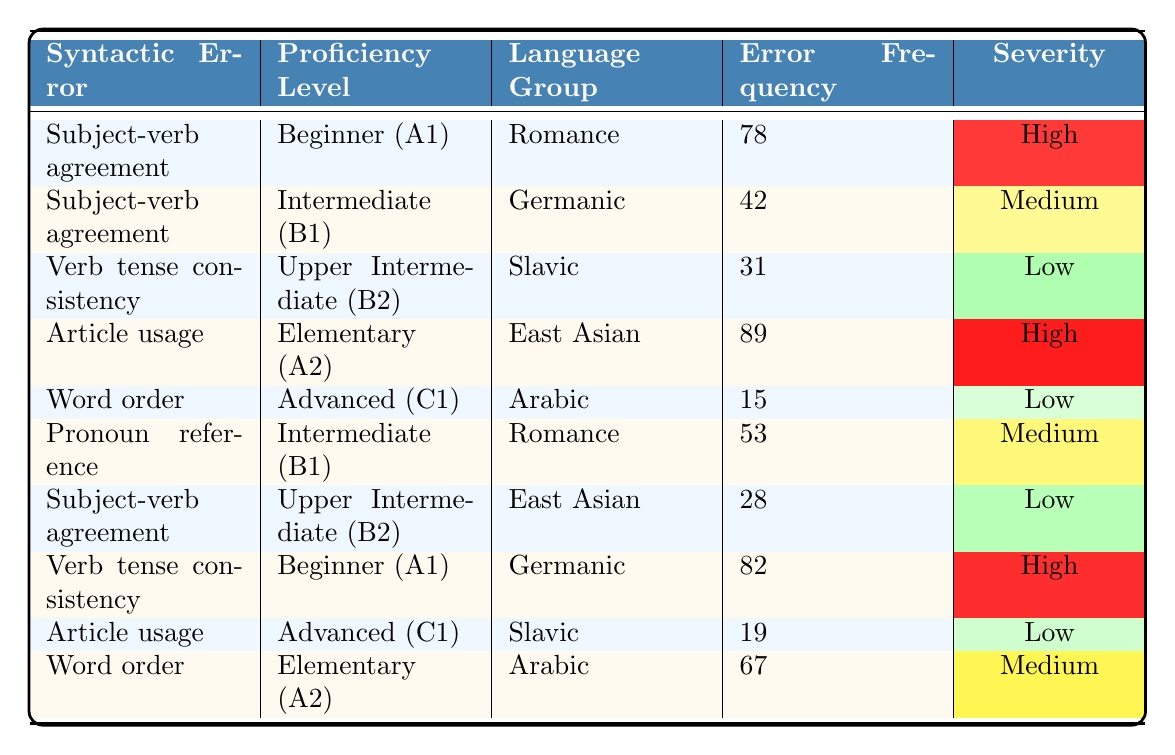What is the highest frequency of syntactic errors in the table? The highest error frequency in the table is found in the "Article usage" error type for the "Elementary (A2)" proficiency level with a frequency of 89.
Answer: 89 In which proficiency level does "Verb tense consistency" have the highest error frequency? "Verb tense consistency" appears twice in the table: once for the "Upper Intermediate (B2)" level with a frequency of 31, and once for "Beginner (A1)" with a frequency of 82. Therefore, "Beginner (A1)" has the higher frequency.
Answer: Beginner (A1) What is the total number of syntactic errors recorded for the "Advanced (C1)" proficiency level? The "Advanced (C1)" level has two entries in the table: "Word order" with a frequency of 15 and "Article usage" with a frequency of 19. Summing these gives 15 + 19 = 34.
Answer: 34 Is there any language group that has a high severity for "Subject-verb agreement"? Yes, the "Romance" language group has a "Subject-verb agreement" frequency of 78 categorized as high severity.
Answer: Yes How many different types of syntactic errors are associated with the "Elementary (A2)" proficiency level? The "Elementary (A2)" level lists two types of errors: "Article usage" with a frequency of 89 and "Verb tense consistency" with a frequency of 71. Thus, there are 2 types associated with this level.
Answer: 2 What is the difference in error frequency between "Word order" in Advanced (C1) and "Word order" in Elementary (A2)? In the table, "Word order" for "Advanced (C1)" has a frequency of 15, while for "Elementary (A2)" it is 67. The difference is 67 - 15 = 52.
Answer: 52 Which language group has the highest error frequency for "Subject-verb agreement"? The "Romance" group has the highest frequency of 78 for "Subject-verb agreement", compared to 12 for the "Germanic" group and 28 for the "East Asian" group.
Answer: Romance For which proficiency level and language group is “Article usage” the error type with the highest frequency? The highest frequency for "Article usage" occurs at the "Elementary (A2)" proficiency level within the "East Asian" language group, with a frequency of 89.
Answer: "Elementary (A2)" and "East Asian" What is the average error frequency of the "Intermediate (B1)" proficiency level? The "Intermediate (B1)" level has two error types: "Pronoun reference" with a frequency of 53 and "Article usage" with a frequency of 59. The sum is 53 + 59 = 112, and dividing this by the number of items (2) gives an average of 56.
Answer: 56 Which proficiency level have the lowest error frequency overall? The "Advanced (C1)" level shows the lowest frequency with "Word order" at 15 and "Article usage" at 19, yielding a maximum of 19. Therefore, this is the lowest proficiency level error frequency.
Answer: Advanced (C1) 